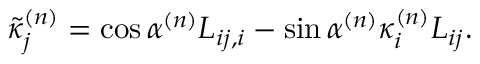<formula> <loc_0><loc_0><loc_500><loc_500>\tilde { \kappa } _ { j } ^ { ( n ) } = \cos \alpha ^ { ( n ) } L _ { i j , i } - \sin \alpha ^ { ( n ) } \kappa _ { i } ^ { ( n ) } L _ { i j } .</formula> 